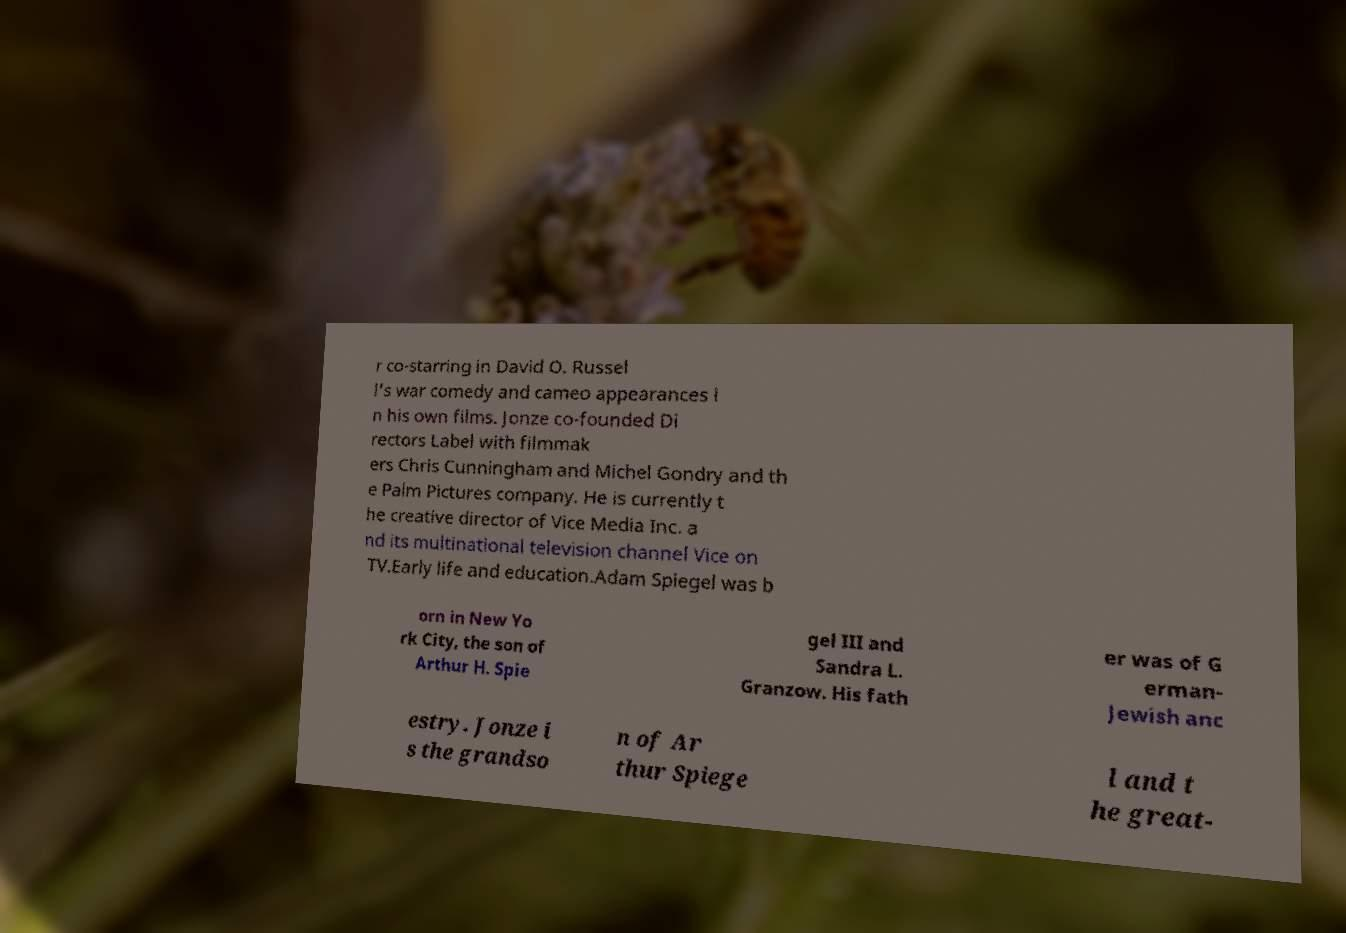Please read and relay the text visible in this image. What does it say? r co-starring in David O. Russel l's war comedy and cameo appearances i n his own films. Jonze co-founded Di rectors Label with filmmak ers Chris Cunningham and Michel Gondry and th e Palm Pictures company. He is currently t he creative director of Vice Media Inc. a nd its multinational television channel Vice on TV.Early life and education.Adam Spiegel was b orn in New Yo rk City, the son of Arthur H. Spie gel III and Sandra L. Granzow. His fath er was of G erman- Jewish anc estry. Jonze i s the grandso n of Ar thur Spiege l and t he great- 